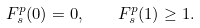Convert formula to latex. <formula><loc_0><loc_0><loc_500><loc_500>F _ { s } ^ { p } ( 0 ) = 0 , \quad F _ { s } ^ { p } ( 1 ) \geq 1 .</formula> 